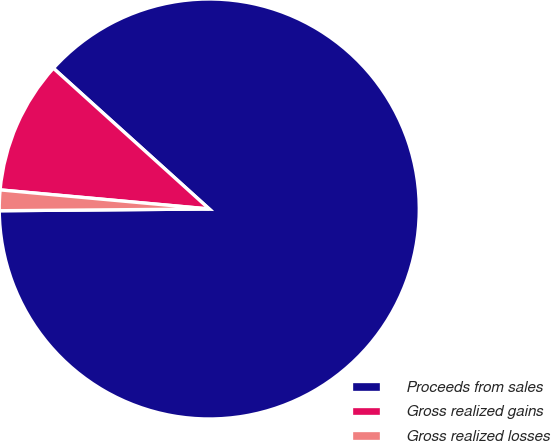Convert chart to OTSL. <chart><loc_0><loc_0><loc_500><loc_500><pie_chart><fcel>Proceeds from sales<fcel>Gross realized gains<fcel>Gross realized losses<nl><fcel>88.17%<fcel>10.24%<fcel>1.58%<nl></chart> 